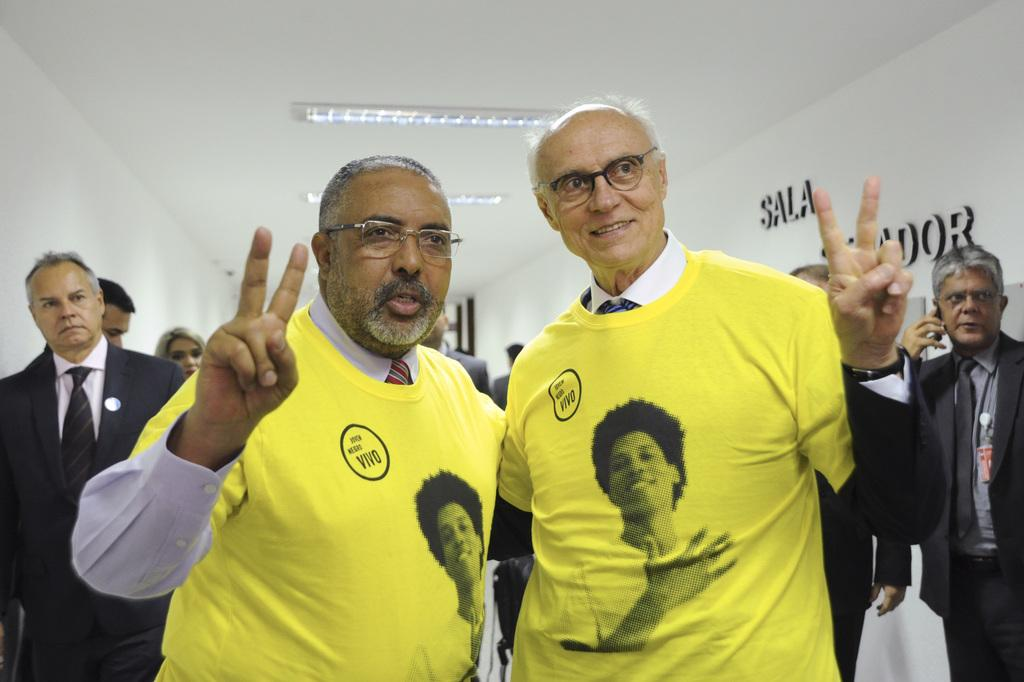How many people are in the image? There are two persons in the image. What are the two persons doing in the image? The two persons are posing for a camera. What can be observed about the appearance of the two persons? Both persons are wearing spectacles. What can be seen in the background of the image? There are other people visible in the background, as well as lights and a wall. What is the relation between the two persons and their grandmother in the image? There is no mention of a grandmother in the image, so we cannot determine the relation between the two persons and a grandmother. 